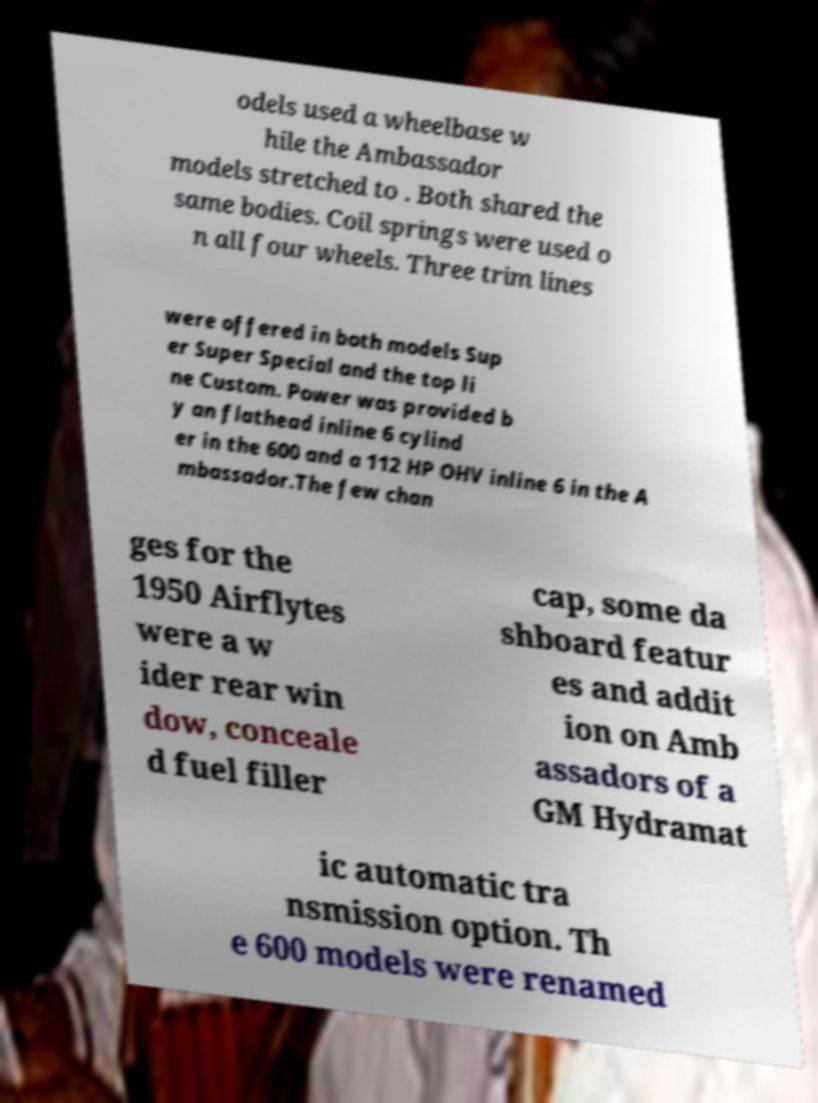Can you read and provide the text displayed in the image?This photo seems to have some interesting text. Can you extract and type it out for me? odels used a wheelbase w hile the Ambassador models stretched to . Both shared the same bodies. Coil springs were used o n all four wheels. Three trim lines were offered in both models Sup er Super Special and the top li ne Custom. Power was provided b y an flathead inline 6 cylind er in the 600 and a 112 HP OHV inline 6 in the A mbassador.The few chan ges for the 1950 Airflytes were a w ider rear win dow, conceale d fuel filler cap, some da shboard featur es and addit ion on Amb assadors of a GM Hydramat ic automatic tra nsmission option. Th e 600 models were renamed 